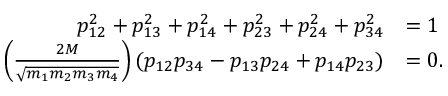Convert formula to latex. <formula><loc_0><loc_0><loc_500><loc_500>\begin{array} { r l } { p _ { 1 2 } ^ { 2 } + p _ { 1 3 } ^ { 2 } + p _ { 1 4 } ^ { 2 } + p _ { 2 3 } ^ { 2 } + p _ { 2 4 } ^ { 2 } + p _ { 3 4 } ^ { 2 } } & { = 1 } \\ { \left ( \frac { 2 M } { \sqrt { m _ { 1 } m _ { 2 } m _ { 3 } m _ { 4 } } } \right ) ( p _ { 1 2 } p _ { 3 4 } - p _ { 1 3 } p _ { 2 4 } + p _ { 1 4 } p _ { 2 3 } ) } & { = 0 . } \end{array}</formula> 